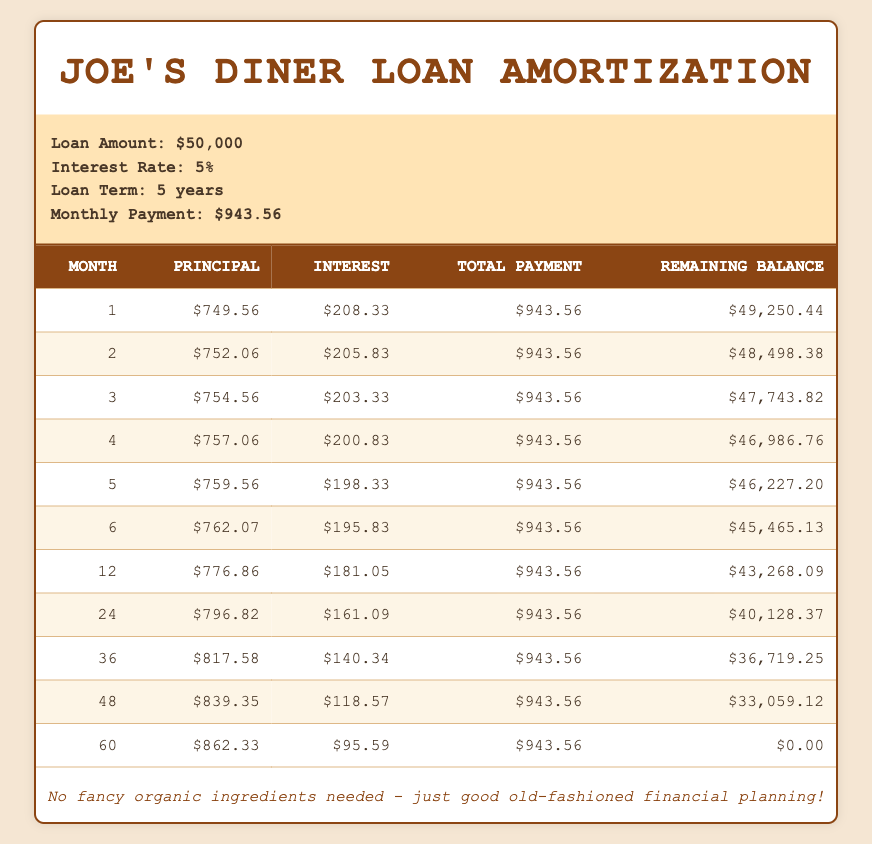What is the monthly payment for the loan? The monthly payment for the loan is directly mentioned in the loan details section of the table. It states that the monthly payment is $943.56.
Answer: $943.56 How much was paid towards the principal in the 3rd month? The principal payment for the 3rd month is listed in the amortization schedule. It shows a principal payment of $754.56 for that month.
Answer: $754.56 What is the total interest payment made in the first year? To find the total interest for the first year, sum the interest payments for months 1 through 12. The interest payments are $208.33, $205.83, $203.33, $200.83, $198.33, $195.83, and decrease until month 12. After adding these values, the total interest for the first year is calculated as $2,382.
Answer: $2,382 Is more principal paid in the 6th month than in the 2nd month? The principal payment in the 6th month is $762.07, and in the 2nd month, it is $752.06. Comparing these values, $762.07 is greater than $752.06, so the statement is true.
Answer: Yes What is the remaining balance after 24 months? Looking at the amortization schedule, the remaining balance after the 24th month is listed as $40,128.37. This value can be found directly in the corresponding row for the 24th month.
Answer: $40,128.37 What is the average principal payment over the first year? To find the average principal payment, sum the principal payments from months 1 to 12 and divide by 12. The total principal for the first year is $749.56 + $752.06 + $754.56 + $757.06 + $759.56 + $762.07 + ... (up to month 12). The average calculates to approximately $754.04.
Answer: $754.04 How much has been paid off the principal by month 48? The total principal paid off by month 48 can be computed by adding the principal payments from months 1 to 48 listed in the table. This gives a total principal payment of $39,940.93, which is derived from the sum of each month's principal payments up to month 48.
Answer: $39,940.93 Is the interest payment in the 36th month lower than in the 12th month? The interest payment in the 36th month is $140.34, while the payment in the 12th month is $181.05. Since $140.34 is less than $181.05, the statement is true.
Answer: Yes What is the remaining balance after the first month? The remaining balance after the first month is stated directly in the table as $49,250.44, located in the row corresponding to month 1.
Answer: $49,250.44 